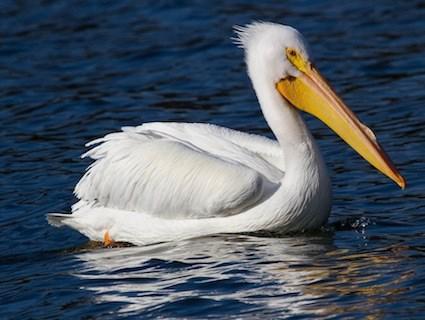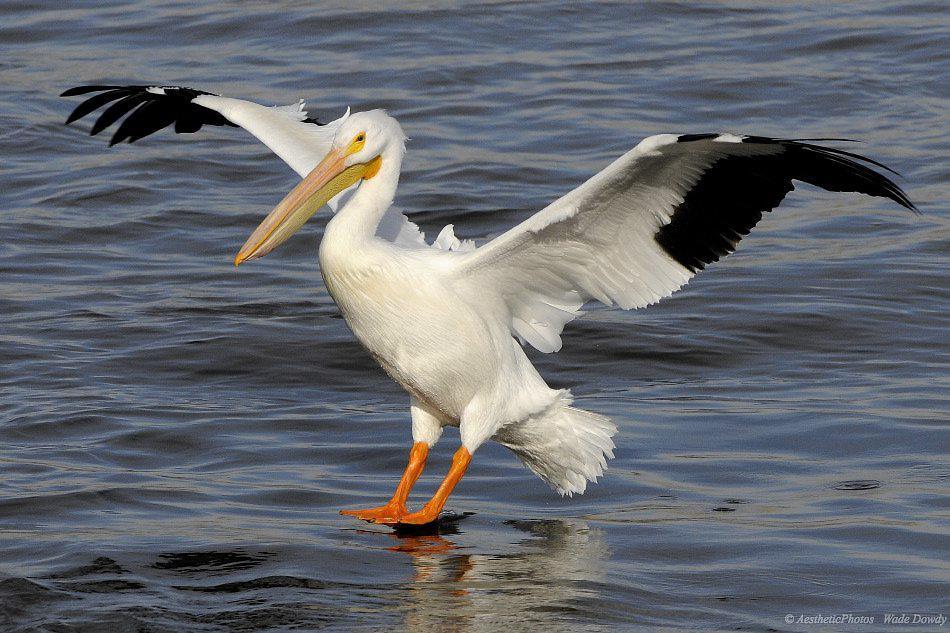The first image is the image on the left, the second image is the image on the right. For the images displayed, is the sentence "There are two pelicans flying" factually correct? Answer yes or no. No. 